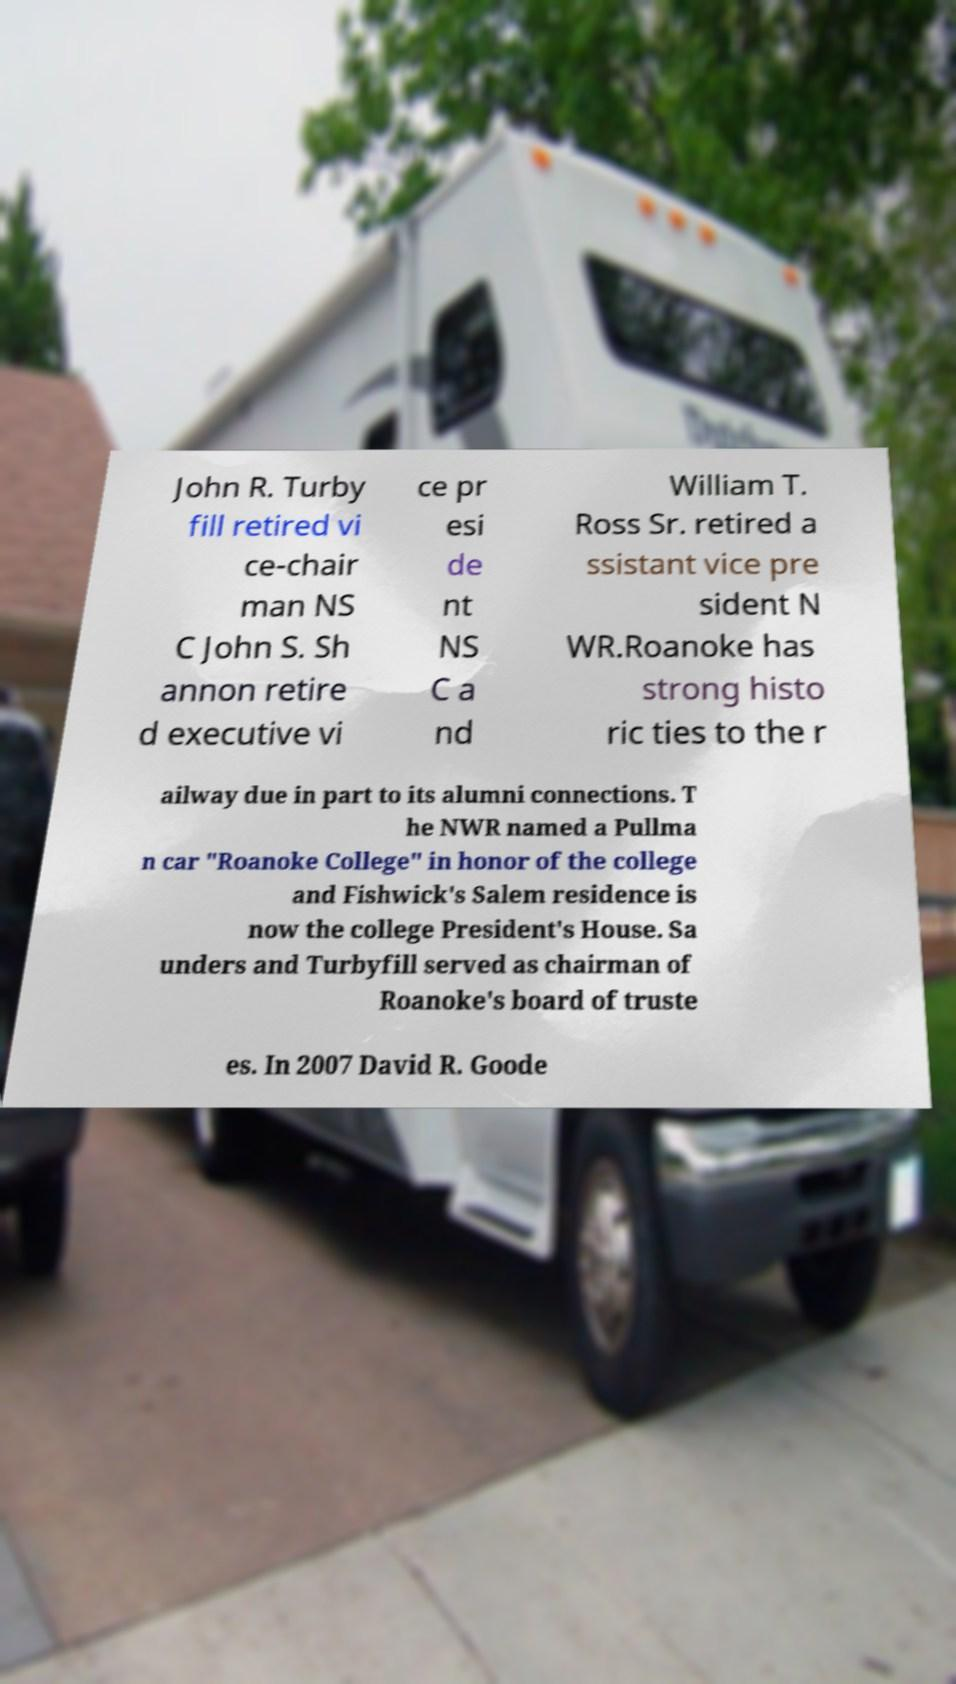Could you extract and type out the text from this image? John R. Turby fill retired vi ce-chair man NS C John S. Sh annon retire d executive vi ce pr esi de nt NS C a nd William T. Ross Sr. retired a ssistant vice pre sident N WR.Roanoke has strong histo ric ties to the r ailway due in part to its alumni connections. T he NWR named a Pullma n car "Roanoke College" in honor of the college and Fishwick's Salem residence is now the college President's House. Sa unders and Turbyfill served as chairman of Roanoke's board of truste es. In 2007 David R. Goode 